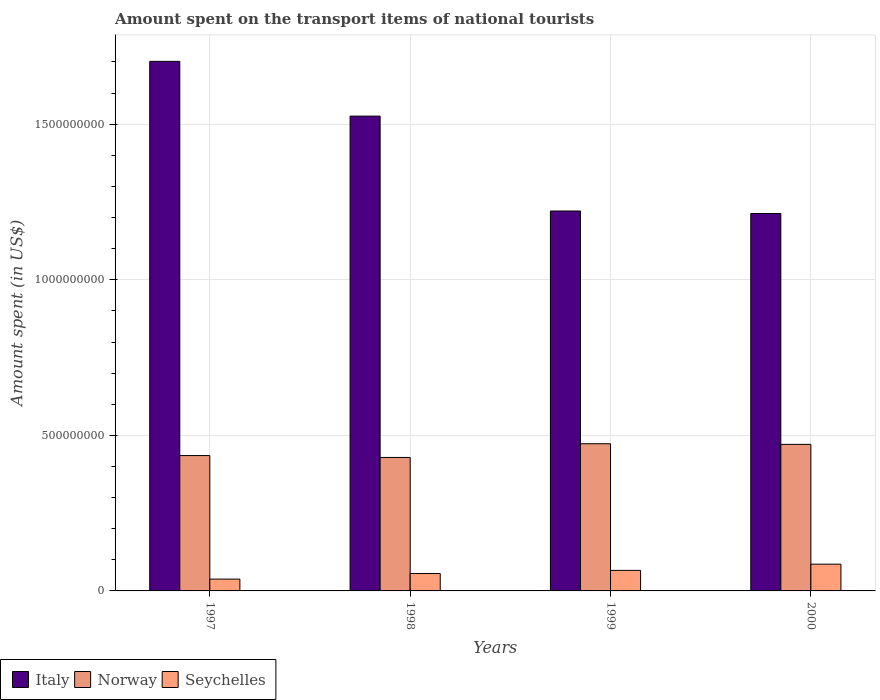How many different coloured bars are there?
Offer a terse response. 3. How many groups of bars are there?
Provide a short and direct response. 4. Are the number of bars per tick equal to the number of legend labels?
Offer a terse response. Yes. Are the number of bars on each tick of the X-axis equal?
Ensure brevity in your answer.  Yes. How many bars are there on the 1st tick from the right?
Provide a succinct answer. 3. In how many cases, is the number of bars for a given year not equal to the number of legend labels?
Provide a short and direct response. 0. What is the amount spent on the transport items of national tourists in Norway in 1999?
Ensure brevity in your answer.  4.73e+08. Across all years, what is the maximum amount spent on the transport items of national tourists in Italy?
Give a very brief answer. 1.70e+09. Across all years, what is the minimum amount spent on the transport items of national tourists in Norway?
Ensure brevity in your answer.  4.29e+08. What is the total amount spent on the transport items of national tourists in Norway in the graph?
Ensure brevity in your answer.  1.81e+09. What is the difference between the amount spent on the transport items of national tourists in Italy in 1997 and that in 1998?
Ensure brevity in your answer.  1.76e+08. What is the difference between the amount spent on the transport items of national tourists in Seychelles in 1997 and the amount spent on the transport items of national tourists in Norway in 1999?
Your answer should be very brief. -4.35e+08. What is the average amount spent on the transport items of national tourists in Italy per year?
Your answer should be compact. 1.42e+09. In the year 1997, what is the difference between the amount spent on the transport items of national tourists in Italy and amount spent on the transport items of national tourists in Norway?
Your answer should be very brief. 1.27e+09. In how many years, is the amount spent on the transport items of national tourists in Italy greater than 700000000 US$?
Offer a terse response. 4. What is the ratio of the amount spent on the transport items of national tourists in Seychelles in 1997 to that in 2000?
Provide a short and direct response. 0.44. Is the amount spent on the transport items of national tourists in Norway in 1997 less than that in 2000?
Provide a succinct answer. Yes. Is the difference between the amount spent on the transport items of national tourists in Italy in 1998 and 2000 greater than the difference between the amount spent on the transport items of national tourists in Norway in 1998 and 2000?
Your response must be concise. Yes. What is the difference between the highest and the second highest amount spent on the transport items of national tourists in Norway?
Offer a terse response. 2.00e+06. What is the difference between the highest and the lowest amount spent on the transport items of national tourists in Seychelles?
Ensure brevity in your answer.  4.80e+07. Is the sum of the amount spent on the transport items of national tourists in Italy in 1998 and 2000 greater than the maximum amount spent on the transport items of national tourists in Norway across all years?
Give a very brief answer. Yes. How many bars are there?
Your answer should be compact. 12. Are all the bars in the graph horizontal?
Provide a short and direct response. No. What is the difference between two consecutive major ticks on the Y-axis?
Provide a succinct answer. 5.00e+08. Are the values on the major ticks of Y-axis written in scientific E-notation?
Give a very brief answer. No. Does the graph contain any zero values?
Your answer should be very brief. No. Does the graph contain grids?
Give a very brief answer. Yes. What is the title of the graph?
Provide a short and direct response. Amount spent on the transport items of national tourists. What is the label or title of the Y-axis?
Make the answer very short. Amount spent (in US$). What is the Amount spent (in US$) of Italy in 1997?
Provide a short and direct response. 1.70e+09. What is the Amount spent (in US$) of Norway in 1997?
Offer a very short reply. 4.35e+08. What is the Amount spent (in US$) in Seychelles in 1997?
Your response must be concise. 3.80e+07. What is the Amount spent (in US$) in Italy in 1998?
Your response must be concise. 1.53e+09. What is the Amount spent (in US$) in Norway in 1998?
Provide a short and direct response. 4.29e+08. What is the Amount spent (in US$) of Seychelles in 1998?
Keep it short and to the point. 5.60e+07. What is the Amount spent (in US$) of Italy in 1999?
Give a very brief answer. 1.22e+09. What is the Amount spent (in US$) of Norway in 1999?
Provide a short and direct response. 4.73e+08. What is the Amount spent (in US$) of Seychelles in 1999?
Your answer should be very brief. 6.60e+07. What is the Amount spent (in US$) in Italy in 2000?
Provide a succinct answer. 1.21e+09. What is the Amount spent (in US$) of Norway in 2000?
Your answer should be compact. 4.71e+08. What is the Amount spent (in US$) of Seychelles in 2000?
Provide a short and direct response. 8.60e+07. Across all years, what is the maximum Amount spent (in US$) of Italy?
Ensure brevity in your answer.  1.70e+09. Across all years, what is the maximum Amount spent (in US$) in Norway?
Provide a short and direct response. 4.73e+08. Across all years, what is the maximum Amount spent (in US$) in Seychelles?
Make the answer very short. 8.60e+07. Across all years, what is the minimum Amount spent (in US$) of Italy?
Keep it short and to the point. 1.21e+09. Across all years, what is the minimum Amount spent (in US$) of Norway?
Ensure brevity in your answer.  4.29e+08. Across all years, what is the minimum Amount spent (in US$) in Seychelles?
Offer a very short reply. 3.80e+07. What is the total Amount spent (in US$) in Italy in the graph?
Offer a terse response. 5.66e+09. What is the total Amount spent (in US$) of Norway in the graph?
Offer a very short reply. 1.81e+09. What is the total Amount spent (in US$) in Seychelles in the graph?
Give a very brief answer. 2.46e+08. What is the difference between the Amount spent (in US$) in Italy in 1997 and that in 1998?
Offer a terse response. 1.76e+08. What is the difference between the Amount spent (in US$) of Norway in 1997 and that in 1998?
Your response must be concise. 6.00e+06. What is the difference between the Amount spent (in US$) in Seychelles in 1997 and that in 1998?
Provide a short and direct response. -1.80e+07. What is the difference between the Amount spent (in US$) in Italy in 1997 and that in 1999?
Provide a succinct answer. 4.81e+08. What is the difference between the Amount spent (in US$) of Norway in 1997 and that in 1999?
Provide a succinct answer. -3.80e+07. What is the difference between the Amount spent (in US$) in Seychelles in 1997 and that in 1999?
Your response must be concise. -2.80e+07. What is the difference between the Amount spent (in US$) in Italy in 1997 and that in 2000?
Provide a short and direct response. 4.89e+08. What is the difference between the Amount spent (in US$) in Norway in 1997 and that in 2000?
Keep it short and to the point. -3.60e+07. What is the difference between the Amount spent (in US$) in Seychelles in 1997 and that in 2000?
Provide a short and direct response. -4.80e+07. What is the difference between the Amount spent (in US$) in Italy in 1998 and that in 1999?
Offer a very short reply. 3.05e+08. What is the difference between the Amount spent (in US$) of Norway in 1998 and that in 1999?
Offer a terse response. -4.40e+07. What is the difference between the Amount spent (in US$) of Seychelles in 1998 and that in 1999?
Keep it short and to the point. -1.00e+07. What is the difference between the Amount spent (in US$) in Italy in 1998 and that in 2000?
Provide a succinct answer. 3.13e+08. What is the difference between the Amount spent (in US$) in Norway in 1998 and that in 2000?
Offer a terse response. -4.20e+07. What is the difference between the Amount spent (in US$) of Seychelles in 1998 and that in 2000?
Give a very brief answer. -3.00e+07. What is the difference between the Amount spent (in US$) of Seychelles in 1999 and that in 2000?
Provide a short and direct response. -2.00e+07. What is the difference between the Amount spent (in US$) in Italy in 1997 and the Amount spent (in US$) in Norway in 1998?
Keep it short and to the point. 1.27e+09. What is the difference between the Amount spent (in US$) of Italy in 1997 and the Amount spent (in US$) of Seychelles in 1998?
Your answer should be very brief. 1.65e+09. What is the difference between the Amount spent (in US$) of Norway in 1997 and the Amount spent (in US$) of Seychelles in 1998?
Offer a very short reply. 3.79e+08. What is the difference between the Amount spent (in US$) in Italy in 1997 and the Amount spent (in US$) in Norway in 1999?
Ensure brevity in your answer.  1.23e+09. What is the difference between the Amount spent (in US$) of Italy in 1997 and the Amount spent (in US$) of Seychelles in 1999?
Ensure brevity in your answer.  1.64e+09. What is the difference between the Amount spent (in US$) in Norway in 1997 and the Amount spent (in US$) in Seychelles in 1999?
Provide a short and direct response. 3.69e+08. What is the difference between the Amount spent (in US$) in Italy in 1997 and the Amount spent (in US$) in Norway in 2000?
Make the answer very short. 1.23e+09. What is the difference between the Amount spent (in US$) of Italy in 1997 and the Amount spent (in US$) of Seychelles in 2000?
Ensure brevity in your answer.  1.62e+09. What is the difference between the Amount spent (in US$) in Norway in 1997 and the Amount spent (in US$) in Seychelles in 2000?
Give a very brief answer. 3.49e+08. What is the difference between the Amount spent (in US$) in Italy in 1998 and the Amount spent (in US$) in Norway in 1999?
Offer a very short reply. 1.05e+09. What is the difference between the Amount spent (in US$) in Italy in 1998 and the Amount spent (in US$) in Seychelles in 1999?
Give a very brief answer. 1.46e+09. What is the difference between the Amount spent (in US$) in Norway in 1998 and the Amount spent (in US$) in Seychelles in 1999?
Give a very brief answer. 3.63e+08. What is the difference between the Amount spent (in US$) in Italy in 1998 and the Amount spent (in US$) in Norway in 2000?
Give a very brief answer. 1.06e+09. What is the difference between the Amount spent (in US$) in Italy in 1998 and the Amount spent (in US$) in Seychelles in 2000?
Your response must be concise. 1.44e+09. What is the difference between the Amount spent (in US$) of Norway in 1998 and the Amount spent (in US$) of Seychelles in 2000?
Your answer should be very brief. 3.43e+08. What is the difference between the Amount spent (in US$) of Italy in 1999 and the Amount spent (in US$) of Norway in 2000?
Your answer should be compact. 7.50e+08. What is the difference between the Amount spent (in US$) in Italy in 1999 and the Amount spent (in US$) in Seychelles in 2000?
Give a very brief answer. 1.14e+09. What is the difference between the Amount spent (in US$) in Norway in 1999 and the Amount spent (in US$) in Seychelles in 2000?
Make the answer very short. 3.87e+08. What is the average Amount spent (in US$) of Italy per year?
Ensure brevity in your answer.  1.42e+09. What is the average Amount spent (in US$) in Norway per year?
Keep it short and to the point. 4.52e+08. What is the average Amount spent (in US$) of Seychelles per year?
Give a very brief answer. 6.15e+07. In the year 1997, what is the difference between the Amount spent (in US$) in Italy and Amount spent (in US$) in Norway?
Provide a succinct answer. 1.27e+09. In the year 1997, what is the difference between the Amount spent (in US$) of Italy and Amount spent (in US$) of Seychelles?
Your answer should be very brief. 1.66e+09. In the year 1997, what is the difference between the Amount spent (in US$) of Norway and Amount spent (in US$) of Seychelles?
Your answer should be compact. 3.97e+08. In the year 1998, what is the difference between the Amount spent (in US$) in Italy and Amount spent (in US$) in Norway?
Your answer should be compact. 1.10e+09. In the year 1998, what is the difference between the Amount spent (in US$) of Italy and Amount spent (in US$) of Seychelles?
Provide a succinct answer. 1.47e+09. In the year 1998, what is the difference between the Amount spent (in US$) of Norway and Amount spent (in US$) of Seychelles?
Make the answer very short. 3.73e+08. In the year 1999, what is the difference between the Amount spent (in US$) in Italy and Amount spent (in US$) in Norway?
Provide a succinct answer. 7.48e+08. In the year 1999, what is the difference between the Amount spent (in US$) in Italy and Amount spent (in US$) in Seychelles?
Your response must be concise. 1.16e+09. In the year 1999, what is the difference between the Amount spent (in US$) of Norway and Amount spent (in US$) of Seychelles?
Give a very brief answer. 4.07e+08. In the year 2000, what is the difference between the Amount spent (in US$) of Italy and Amount spent (in US$) of Norway?
Offer a terse response. 7.42e+08. In the year 2000, what is the difference between the Amount spent (in US$) in Italy and Amount spent (in US$) in Seychelles?
Offer a terse response. 1.13e+09. In the year 2000, what is the difference between the Amount spent (in US$) of Norway and Amount spent (in US$) of Seychelles?
Keep it short and to the point. 3.85e+08. What is the ratio of the Amount spent (in US$) in Italy in 1997 to that in 1998?
Offer a terse response. 1.12. What is the ratio of the Amount spent (in US$) in Seychelles in 1997 to that in 1998?
Provide a short and direct response. 0.68. What is the ratio of the Amount spent (in US$) of Italy in 1997 to that in 1999?
Your answer should be compact. 1.39. What is the ratio of the Amount spent (in US$) in Norway in 1997 to that in 1999?
Give a very brief answer. 0.92. What is the ratio of the Amount spent (in US$) in Seychelles in 1997 to that in 1999?
Your response must be concise. 0.58. What is the ratio of the Amount spent (in US$) in Italy in 1997 to that in 2000?
Offer a very short reply. 1.4. What is the ratio of the Amount spent (in US$) in Norway in 1997 to that in 2000?
Your answer should be compact. 0.92. What is the ratio of the Amount spent (in US$) in Seychelles in 1997 to that in 2000?
Your answer should be very brief. 0.44. What is the ratio of the Amount spent (in US$) of Italy in 1998 to that in 1999?
Keep it short and to the point. 1.25. What is the ratio of the Amount spent (in US$) of Norway in 1998 to that in 1999?
Give a very brief answer. 0.91. What is the ratio of the Amount spent (in US$) of Seychelles in 1998 to that in 1999?
Make the answer very short. 0.85. What is the ratio of the Amount spent (in US$) of Italy in 1998 to that in 2000?
Give a very brief answer. 1.26. What is the ratio of the Amount spent (in US$) in Norway in 1998 to that in 2000?
Offer a terse response. 0.91. What is the ratio of the Amount spent (in US$) in Seychelles in 1998 to that in 2000?
Provide a succinct answer. 0.65. What is the ratio of the Amount spent (in US$) in Italy in 1999 to that in 2000?
Give a very brief answer. 1.01. What is the ratio of the Amount spent (in US$) of Norway in 1999 to that in 2000?
Make the answer very short. 1. What is the ratio of the Amount spent (in US$) of Seychelles in 1999 to that in 2000?
Your answer should be compact. 0.77. What is the difference between the highest and the second highest Amount spent (in US$) of Italy?
Keep it short and to the point. 1.76e+08. What is the difference between the highest and the second highest Amount spent (in US$) of Norway?
Offer a very short reply. 2.00e+06. What is the difference between the highest and the lowest Amount spent (in US$) of Italy?
Your answer should be compact. 4.89e+08. What is the difference between the highest and the lowest Amount spent (in US$) in Norway?
Keep it short and to the point. 4.40e+07. What is the difference between the highest and the lowest Amount spent (in US$) in Seychelles?
Ensure brevity in your answer.  4.80e+07. 